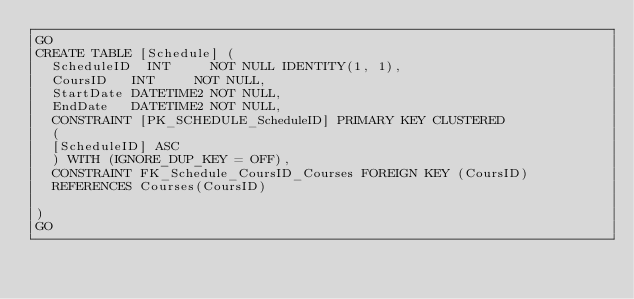Convert code to text. <code><loc_0><loc_0><loc_500><loc_500><_SQL_>GO
CREATE TABLE [Schedule] (
	ScheduleID	INT			NOT NULL IDENTITY(1, 1),
	CoursID		INT			NOT NULL,
	StartDate	DATETIME2	NOT NULL,
	EndDate		DATETIME2	NOT NULL,
  CONSTRAINT [PK_SCHEDULE_ScheduleID] PRIMARY KEY CLUSTERED
  (
  [ScheduleID] ASC
  ) WITH (IGNORE_DUP_KEY = OFF),
  CONSTRAINT FK_Schedule_CoursID_Courses FOREIGN KEY (CoursID)
	REFERENCES Courses(CoursID)

)
GO



</code> 